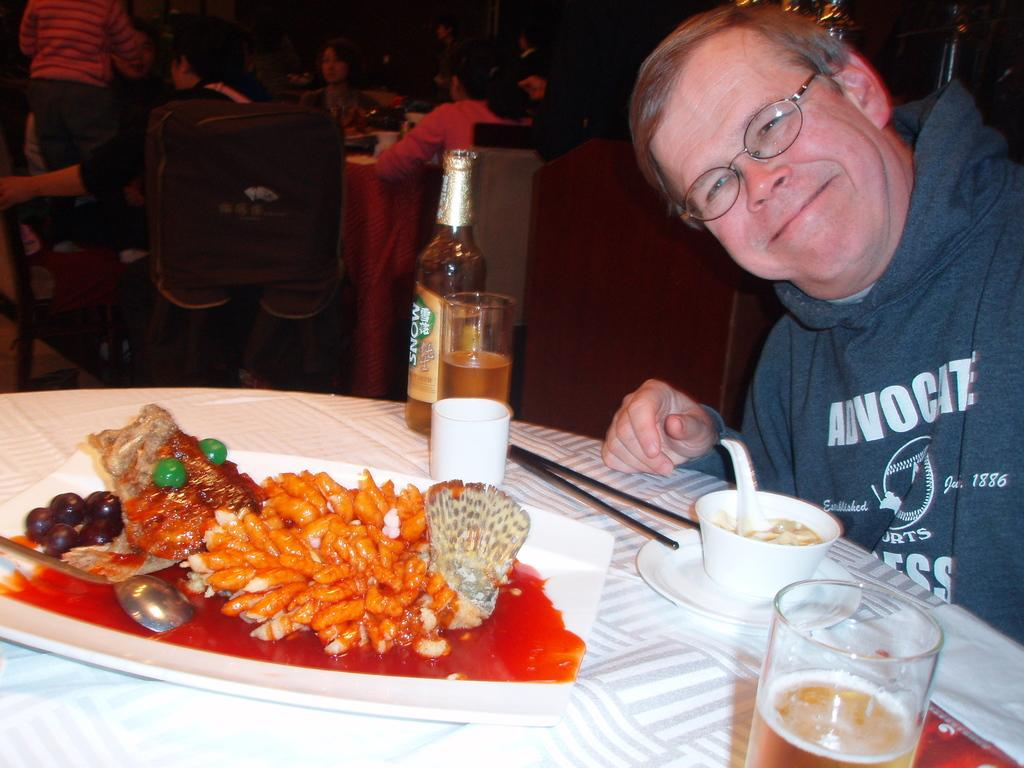Who is present in the image? There is a man in the image. What is the man doing in the image? The man is sitting on a chair. Where is the chair located in relation to the table? The chair is in front of a table. What can be found on the table? There are food items and at least one bottle on the table. What type of stocking is the giant wearing in the image? There are no giants or stockings present in the image. 